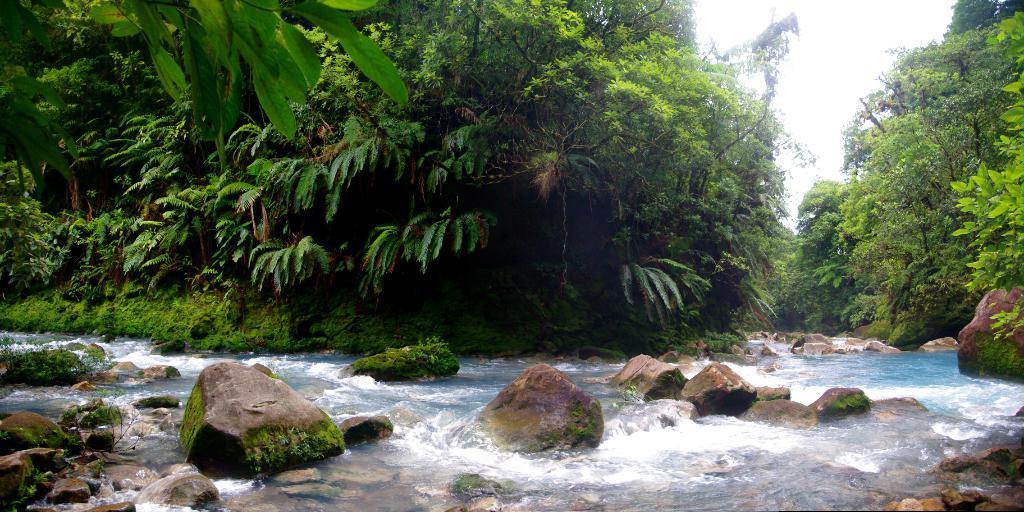Please provide a concise description of this image. This image is taken outdoors. At the top of the image there is the sky. In the background there are many trees and plants with leaves, stems and branches and there is a ground with grass on it. In the middle of the image there is a lake with water. There are many rocks and stones. 